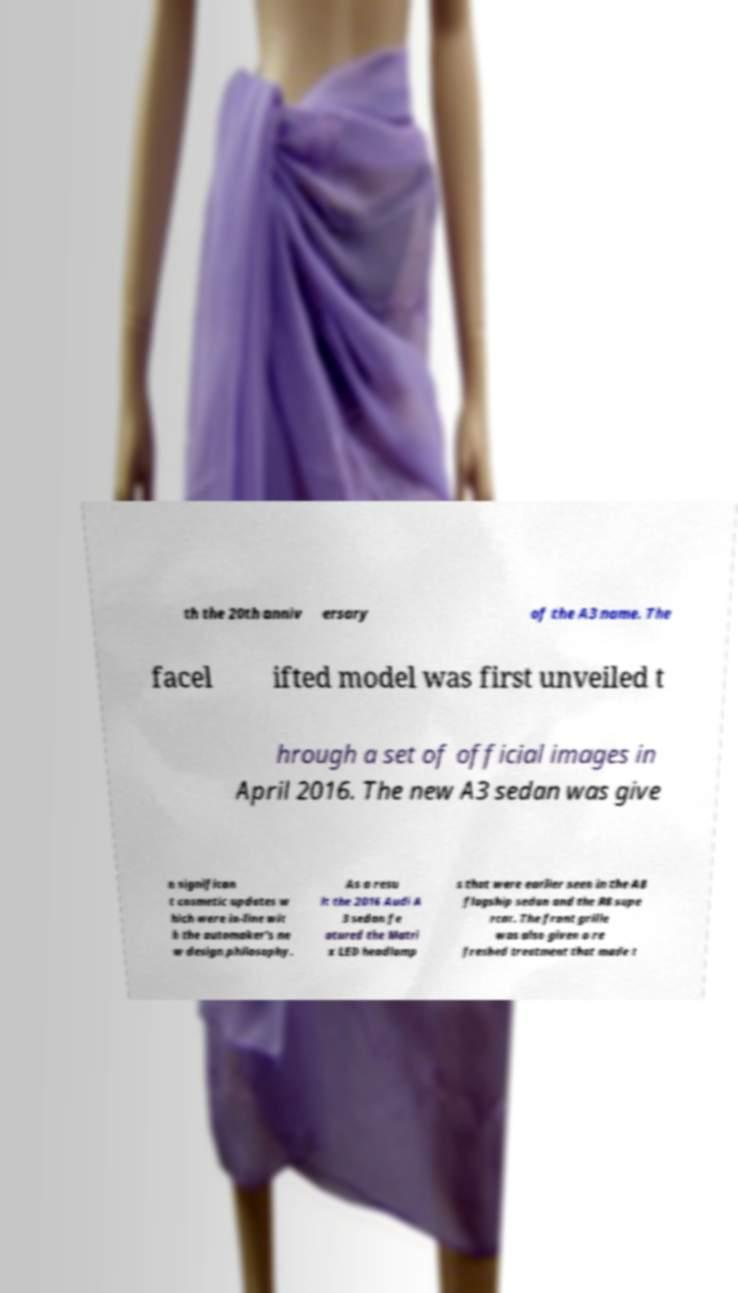For documentation purposes, I need the text within this image transcribed. Could you provide that? th the 20th anniv ersary of the A3 name. The facel ifted model was first unveiled t hrough a set of official images in April 2016. The new A3 sedan was give n significan t cosmetic updates w hich were in-line wit h the automaker's ne w design philosophy. As a resu lt the 2016 Audi A 3 sedan fe atured the Matri x LED headlamp s that were earlier seen in the A8 flagship sedan and the R8 supe rcar. The front grille was also given a re freshed treatment that made t 